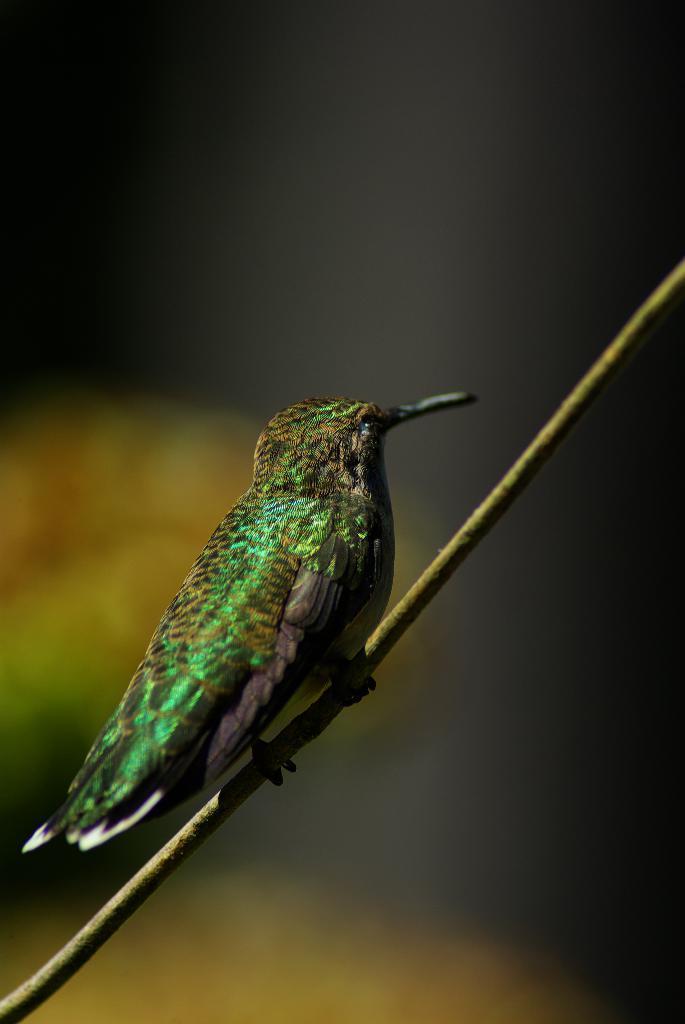What type of animal is in the image? There is a bird in the image. Where is the bird located? The bird is on a stem. Can you describe the background of the image? The background of the image is blurred. What type of wound can be seen on the bird's wing in the image? There is no wound visible on the bird's wing in the image. 